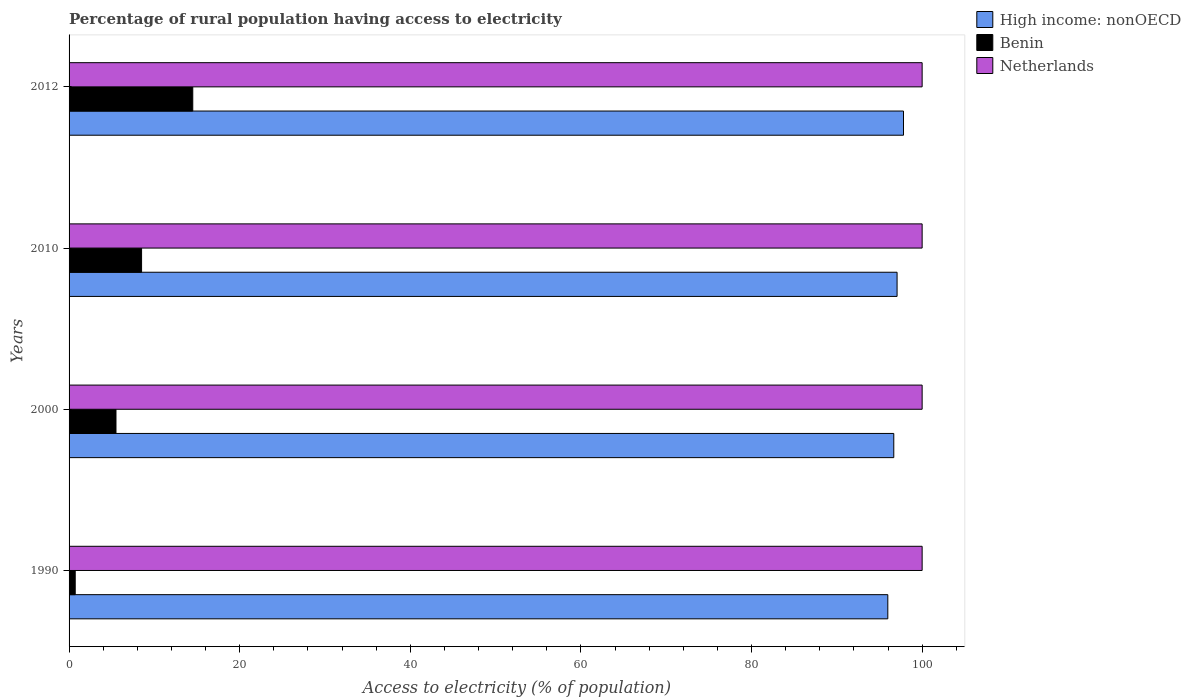Are the number of bars per tick equal to the number of legend labels?
Give a very brief answer. Yes. Are the number of bars on each tick of the Y-axis equal?
Provide a succinct answer. Yes. In how many cases, is the number of bars for a given year not equal to the number of legend labels?
Offer a terse response. 0. What is the percentage of rural population having access to electricity in High income: nonOECD in 2010?
Give a very brief answer. 97.06. Across all years, what is the maximum percentage of rural population having access to electricity in Benin?
Keep it short and to the point. 14.5. Across all years, what is the minimum percentage of rural population having access to electricity in High income: nonOECD?
Your response must be concise. 95.98. What is the total percentage of rural population having access to electricity in Netherlands in the graph?
Give a very brief answer. 400. What is the difference between the percentage of rural population having access to electricity in Netherlands in 1990 and that in 2000?
Offer a terse response. 0. What is the difference between the percentage of rural population having access to electricity in Netherlands in 2010 and the percentage of rural population having access to electricity in High income: nonOECD in 2012?
Keep it short and to the point. 2.18. What is the average percentage of rural population having access to electricity in Netherlands per year?
Provide a short and direct response. 100. In the year 2010, what is the difference between the percentage of rural population having access to electricity in Benin and percentage of rural population having access to electricity in High income: nonOECD?
Ensure brevity in your answer.  -88.56. In how many years, is the percentage of rural population having access to electricity in Netherlands greater than 40 %?
Offer a very short reply. 4. What is the ratio of the percentage of rural population having access to electricity in Benin in 2000 to that in 2010?
Offer a terse response. 0.65. Is the percentage of rural population having access to electricity in High income: nonOECD in 2000 less than that in 2012?
Provide a short and direct response. Yes. Is the difference between the percentage of rural population having access to electricity in Benin in 1990 and 2000 greater than the difference between the percentage of rural population having access to electricity in High income: nonOECD in 1990 and 2000?
Your answer should be very brief. No. What is the difference between the highest and the lowest percentage of rural population having access to electricity in High income: nonOECD?
Give a very brief answer. 1.84. Is the sum of the percentage of rural population having access to electricity in Benin in 2000 and 2010 greater than the maximum percentage of rural population having access to electricity in High income: nonOECD across all years?
Give a very brief answer. No. What does the 1st bar from the top in 1990 represents?
Keep it short and to the point. Netherlands. What does the 2nd bar from the bottom in 1990 represents?
Give a very brief answer. Benin. Are all the bars in the graph horizontal?
Provide a succinct answer. Yes. What is the difference between two consecutive major ticks on the X-axis?
Offer a terse response. 20. Where does the legend appear in the graph?
Your answer should be very brief. Top right. How many legend labels are there?
Offer a terse response. 3. How are the legend labels stacked?
Provide a short and direct response. Vertical. What is the title of the graph?
Offer a very short reply. Percentage of rural population having access to electricity. What is the label or title of the X-axis?
Provide a short and direct response. Access to electricity (% of population). What is the label or title of the Y-axis?
Make the answer very short. Years. What is the Access to electricity (% of population) of High income: nonOECD in 1990?
Offer a very short reply. 95.98. What is the Access to electricity (% of population) of Benin in 1990?
Offer a terse response. 0.72. What is the Access to electricity (% of population) of Netherlands in 1990?
Make the answer very short. 100. What is the Access to electricity (% of population) of High income: nonOECD in 2000?
Ensure brevity in your answer.  96.68. What is the Access to electricity (% of population) of High income: nonOECD in 2010?
Offer a very short reply. 97.06. What is the Access to electricity (% of population) of Benin in 2010?
Make the answer very short. 8.5. What is the Access to electricity (% of population) of Netherlands in 2010?
Your answer should be compact. 100. What is the Access to electricity (% of population) in High income: nonOECD in 2012?
Give a very brief answer. 97.82. What is the Access to electricity (% of population) of Netherlands in 2012?
Provide a short and direct response. 100. Across all years, what is the maximum Access to electricity (% of population) in High income: nonOECD?
Provide a succinct answer. 97.82. Across all years, what is the maximum Access to electricity (% of population) in Netherlands?
Your response must be concise. 100. Across all years, what is the minimum Access to electricity (% of population) in High income: nonOECD?
Provide a short and direct response. 95.98. Across all years, what is the minimum Access to electricity (% of population) of Benin?
Keep it short and to the point. 0.72. What is the total Access to electricity (% of population) in High income: nonOECD in the graph?
Your answer should be compact. 387.53. What is the total Access to electricity (% of population) of Benin in the graph?
Keep it short and to the point. 29.22. What is the total Access to electricity (% of population) in Netherlands in the graph?
Give a very brief answer. 400. What is the difference between the Access to electricity (% of population) in High income: nonOECD in 1990 and that in 2000?
Offer a very short reply. -0.7. What is the difference between the Access to electricity (% of population) of Benin in 1990 and that in 2000?
Your answer should be very brief. -4.78. What is the difference between the Access to electricity (% of population) of Netherlands in 1990 and that in 2000?
Ensure brevity in your answer.  0. What is the difference between the Access to electricity (% of population) of High income: nonOECD in 1990 and that in 2010?
Provide a short and direct response. -1.08. What is the difference between the Access to electricity (% of population) in Benin in 1990 and that in 2010?
Give a very brief answer. -7.78. What is the difference between the Access to electricity (% of population) of High income: nonOECD in 1990 and that in 2012?
Make the answer very short. -1.84. What is the difference between the Access to electricity (% of population) of Benin in 1990 and that in 2012?
Give a very brief answer. -13.78. What is the difference between the Access to electricity (% of population) of Netherlands in 1990 and that in 2012?
Offer a very short reply. 0. What is the difference between the Access to electricity (% of population) in High income: nonOECD in 2000 and that in 2010?
Offer a very short reply. -0.39. What is the difference between the Access to electricity (% of population) of High income: nonOECD in 2000 and that in 2012?
Your response must be concise. -1.14. What is the difference between the Access to electricity (% of population) of Benin in 2000 and that in 2012?
Ensure brevity in your answer.  -9. What is the difference between the Access to electricity (% of population) of High income: nonOECD in 2010 and that in 2012?
Make the answer very short. -0.75. What is the difference between the Access to electricity (% of population) in High income: nonOECD in 1990 and the Access to electricity (% of population) in Benin in 2000?
Provide a short and direct response. 90.48. What is the difference between the Access to electricity (% of population) of High income: nonOECD in 1990 and the Access to electricity (% of population) of Netherlands in 2000?
Ensure brevity in your answer.  -4.02. What is the difference between the Access to electricity (% of population) of Benin in 1990 and the Access to electricity (% of population) of Netherlands in 2000?
Provide a succinct answer. -99.28. What is the difference between the Access to electricity (% of population) of High income: nonOECD in 1990 and the Access to electricity (% of population) of Benin in 2010?
Keep it short and to the point. 87.48. What is the difference between the Access to electricity (% of population) of High income: nonOECD in 1990 and the Access to electricity (% of population) of Netherlands in 2010?
Offer a terse response. -4.02. What is the difference between the Access to electricity (% of population) of Benin in 1990 and the Access to electricity (% of population) of Netherlands in 2010?
Your answer should be very brief. -99.28. What is the difference between the Access to electricity (% of population) of High income: nonOECD in 1990 and the Access to electricity (% of population) of Benin in 2012?
Provide a succinct answer. 81.48. What is the difference between the Access to electricity (% of population) of High income: nonOECD in 1990 and the Access to electricity (% of population) of Netherlands in 2012?
Give a very brief answer. -4.02. What is the difference between the Access to electricity (% of population) of Benin in 1990 and the Access to electricity (% of population) of Netherlands in 2012?
Give a very brief answer. -99.28. What is the difference between the Access to electricity (% of population) in High income: nonOECD in 2000 and the Access to electricity (% of population) in Benin in 2010?
Provide a short and direct response. 88.18. What is the difference between the Access to electricity (% of population) in High income: nonOECD in 2000 and the Access to electricity (% of population) in Netherlands in 2010?
Offer a very short reply. -3.32. What is the difference between the Access to electricity (% of population) in Benin in 2000 and the Access to electricity (% of population) in Netherlands in 2010?
Your answer should be compact. -94.5. What is the difference between the Access to electricity (% of population) in High income: nonOECD in 2000 and the Access to electricity (% of population) in Benin in 2012?
Your response must be concise. 82.18. What is the difference between the Access to electricity (% of population) of High income: nonOECD in 2000 and the Access to electricity (% of population) of Netherlands in 2012?
Ensure brevity in your answer.  -3.32. What is the difference between the Access to electricity (% of population) of Benin in 2000 and the Access to electricity (% of population) of Netherlands in 2012?
Make the answer very short. -94.5. What is the difference between the Access to electricity (% of population) of High income: nonOECD in 2010 and the Access to electricity (% of population) of Benin in 2012?
Keep it short and to the point. 82.56. What is the difference between the Access to electricity (% of population) of High income: nonOECD in 2010 and the Access to electricity (% of population) of Netherlands in 2012?
Your answer should be very brief. -2.94. What is the difference between the Access to electricity (% of population) of Benin in 2010 and the Access to electricity (% of population) of Netherlands in 2012?
Your response must be concise. -91.5. What is the average Access to electricity (% of population) in High income: nonOECD per year?
Your answer should be very brief. 96.88. What is the average Access to electricity (% of population) in Benin per year?
Provide a succinct answer. 7.3. In the year 1990, what is the difference between the Access to electricity (% of population) of High income: nonOECD and Access to electricity (% of population) of Benin?
Give a very brief answer. 95.26. In the year 1990, what is the difference between the Access to electricity (% of population) in High income: nonOECD and Access to electricity (% of population) in Netherlands?
Offer a terse response. -4.02. In the year 1990, what is the difference between the Access to electricity (% of population) of Benin and Access to electricity (% of population) of Netherlands?
Make the answer very short. -99.28. In the year 2000, what is the difference between the Access to electricity (% of population) in High income: nonOECD and Access to electricity (% of population) in Benin?
Your response must be concise. 91.18. In the year 2000, what is the difference between the Access to electricity (% of population) of High income: nonOECD and Access to electricity (% of population) of Netherlands?
Ensure brevity in your answer.  -3.32. In the year 2000, what is the difference between the Access to electricity (% of population) in Benin and Access to electricity (% of population) in Netherlands?
Give a very brief answer. -94.5. In the year 2010, what is the difference between the Access to electricity (% of population) of High income: nonOECD and Access to electricity (% of population) of Benin?
Your response must be concise. 88.56. In the year 2010, what is the difference between the Access to electricity (% of population) in High income: nonOECD and Access to electricity (% of population) in Netherlands?
Keep it short and to the point. -2.94. In the year 2010, what is the difference between the Access to electricity (% of population) of Benin and Access to electricity (% of population) of Netherlands?
Give a very brief answer. -91.5. In the year 2012, what is the difference between the Access to electricity (% of population) of High income: nonOECD and Access to electricity (% of population) of Benin?
Make the answer very short. 83.32. In the year 2012, what is the difference between the Access to electricity (% of population) in High income: nonOECD and Access to electricity (% of population) in Netherlands?
Your response must be concise. -2.18. In the year 2012, what is the difference between the Access to electricity (% of population) of Benin and Access to electricity (% of population) of Netherlands?
Give a very brief answer. -85.5. What is the ratio of the Access to electricity (% of population) in Benin in 1990 to that in 2000?
Your answer should be compact. 0.13. What is the ratio of the Access to electricity (% of population) of Benin in 1990 to that in 2010?
Ensure brevity in your answer.  0.08. What is the ratio of the Access to electricity (% of population) of High income: nonOECD in 1990 to that in 2012?
Offer a very short reply. 0.98. What is the ratio of the Access to electricity (% of population) of Benin in 1990 to that in 2012?
Provide a succinct answer. 0.05. What is the ratio of the Access to electricity (% of population) of Benin in 2000 to that in 2010?
Offer a very short reply. 0.65. What is the ratio of the Access to electricity (% of population) in Netherlands in 2000 to that in 2010?
Keep it short and to the point. 1. What is the ratio of the Access to electricity (% of population) of High income: nonOECD in 2000 to that in 2012?
Your response must be concise. 0.99. What is the ratio of the Access to electricity (% of population) of Benin in 2000 to that in 2012?
Your answer should be very brief. 0.38. What is the ratio of the Access to electricity (% of population) of Benin in 2010 to that in 2012?
Provide a short and direct response. 0.59. What is the ratio of the Access to electricity (% of population) of Netherlands in 2010 to that in 2012?
Keep it short and to the point. 1. What is the difference between the highest and the second highest Access to electricity (% of population) in High income: nonOECD?
Ensure brevity in your answer.  0.75. What is the difference between the highest and the second highest Access to electricity (% of population) in Benin?
Offer a very short reply. 6. What is the difference between the highest and the lowest Access to electricity (% of population) of High income: nonOECD?
Provide a short and direct response. 1.84. What is the difference between the highest and the lowest Access to electricity (% of population) in Benin?
Offer a very short reply. 13.78. What is the difference between the highest and the lowest Access to electricity (% of population) in Netherlands?
Offer a very short reply. 0. 